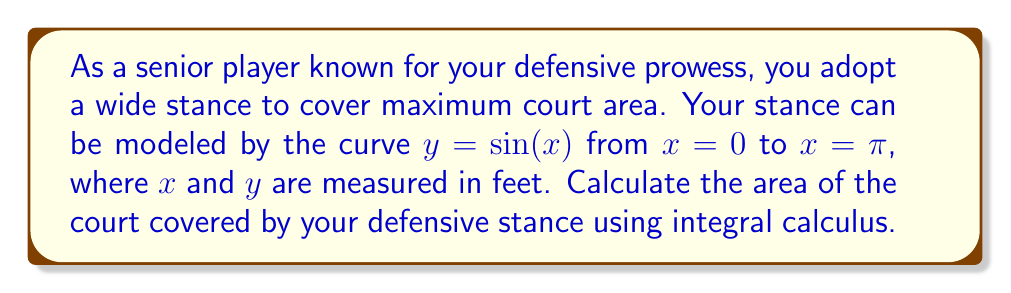What is the answer to this math problem? To find the area covered by the defensive stance, we need to calculate the area under the curve $y = \sin(x)$ from $x = 0$ to $x = \pi$. This can be done using a definite integral.

Step 1: Set up the integral
$$A = \int_0^\pi \sin(x) dx$$

Step 2: Recall the antiderivative of $\sin(x)$ is $-\cos(x)$
$$A = [-\cos(x)]_0^\pi$$

Step 3: Evaluate the integral
$$A = [-\cos(\pi)] - [-\cos(0)]$$
$$A = [1] - [-1]$$
$$A = 1 + 1 = 2$$

Step 4: Interpret the result
The area is 2 square feet. However, this represents only half of the total area covered by the stance, as the curve $y = \sin(x)$ from 0 to $\pi$ forms a semicircle-like shape.

Step 5: Calculate the total area
Total area = $2 \times 2 = 4$ square feet

Therefore, the total area of the court covered by the player's defensive stance is 4 square feet.
Answer: 4 sq ft 